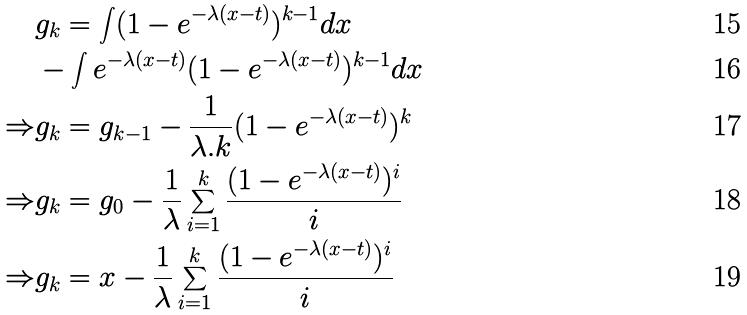<formula> <loc_0><loc_0><loc_500><loc_500>& g _ { k } = \int ( 1 - e ^ { - \lambda ( x - t ) } ) ^ { k - 1 } d x \\ & - \int e ^ { - \lambda ( x - t ) } ( 1 - e ^ { - \lambda ( x - t ) } ) ^ { k - 1 } d x \\ \Rightarrow & g _ { k } = g _ { k - 1 } - \frac { 1 } { \lambda . k } ( 1 - e ^ { - \lambda ( x - t ) } ) ^ { k } \\ \Rightarrow & g _ { k } = g _ { 0 } - \frac { 1 } { \lambda } \sum _ { i = 1 } ^ { k } \frac { ( 1 - e ^ { - \lambda ( x - t ) } ) ^ { i } } { i } \\ \Rightarrow & g _ { k } = x - \frac { 1 } { \lambda } \sum _ { i = 1 } ^ { k } \frac { ( 1 - e ^ { - \lambda ( x - t ) } ) ^ { i } } { i }</formula> 